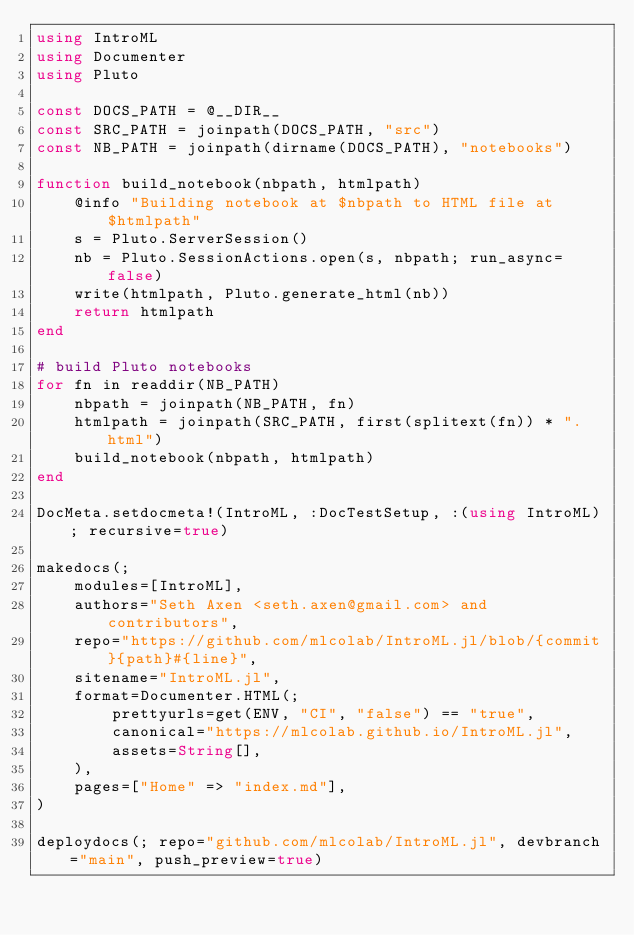Convert code to text. <code><loc_0><loc_0><loc_500><loc_500><_Julia_>using IntroML
using Documenter
using Pluto

const DOCS_PATH = @__DIR__
const SRC_PATH = joinpath(DOCS_PATH, "src")
const NB_PATH = joinpath(dirname(DOCS_PATH), "notebooks")

function build_notebook(nbpath, htmlpath)
    @info "Building notebook at $nbpath to HTML file at $htmlpath"
    s = Pluto.ServerSession()
    nb = Pluto.SessionActions.open(s, nbpath; run_async=false)
    write(htmlpath, Pluto.generate_html(nb))
    return htmlpath
end

# build Pluto notebooks
for fn in readdir(NB_PATH)
    nbpath = joinpath(NB_PATH, fn)
    htmlpath = joinpath(SRC_PATH, first(splitext(fn)) * ".html")
    build_notebook(nbpath, htmlpath)
end

DocMeta.setdocmeta!(IntroML, :DocTestSetup, :(using IntroML); recursive=true)

makedocs(;
    modules=[IntroML],
    authors="Seth Axen <seth.axen@gmail.com> and contributors",
    repo="https://github.com/mlcolab/IntroML.jl/blob/{commit}{path}#{line}",
    sitename="IntroML.jl",
    format=Documenter.HTML(;
        prettyurls=get(ENV, "CI", "false") == "true",
        canonical="https://mlcolab.github.io/IntroML.jl",
        assets=String[],
    ),
    pages=["Home" => "index.md"],
)

deploydocs(; repo="github.com/mlcolab/IntroML.jl", devbranch="main", push_preview=true)
</code> 